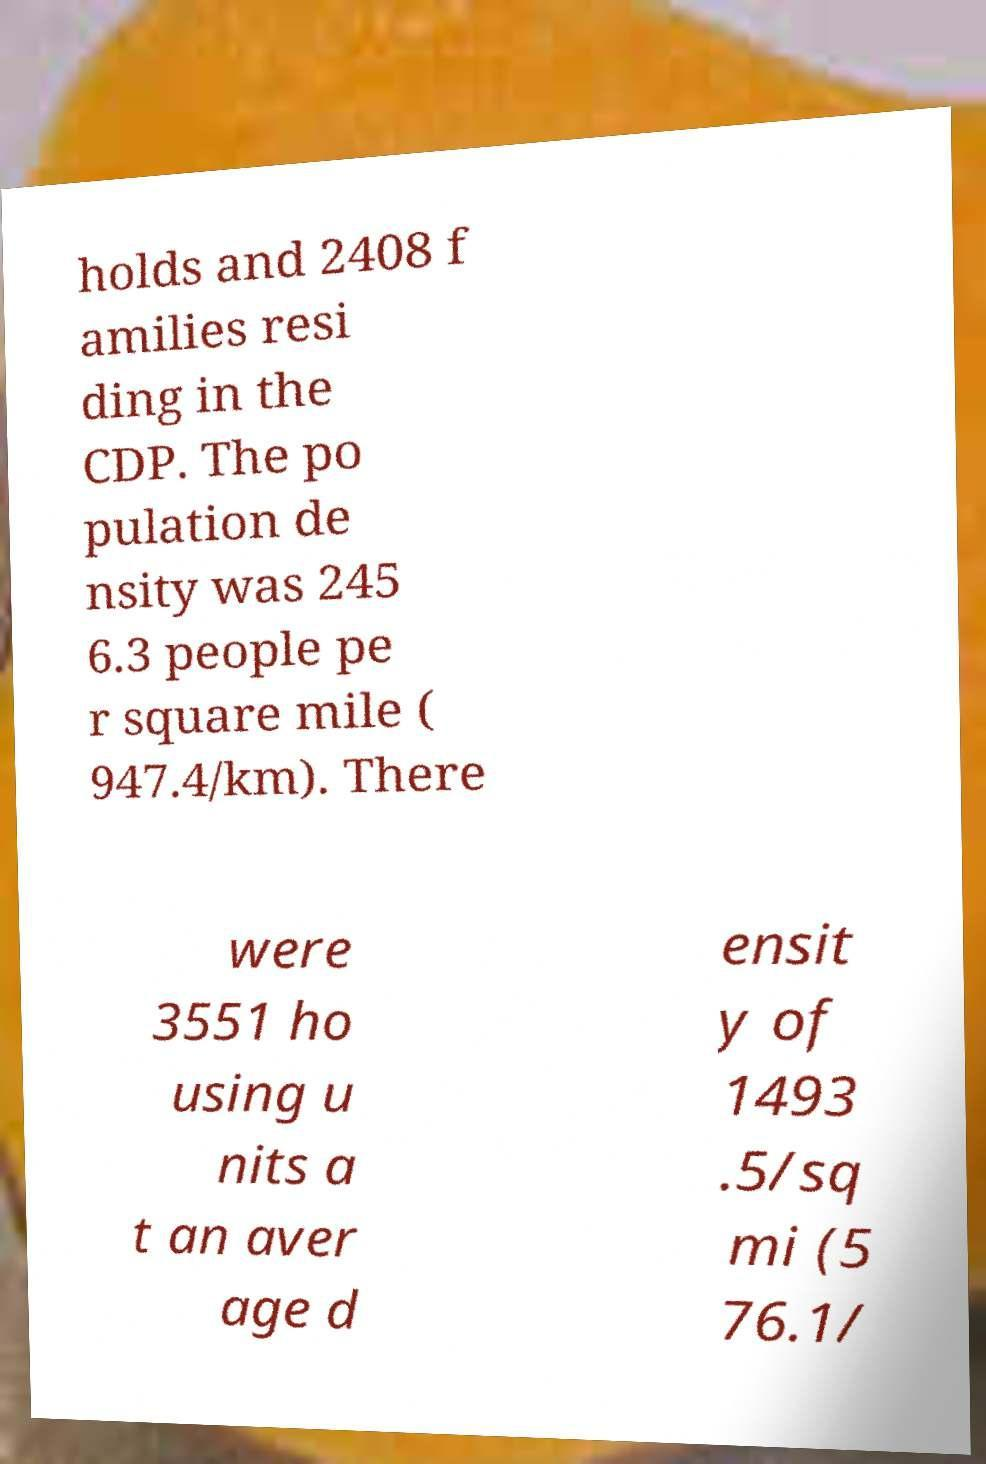There's text embedded in this image that I need extracted. Can you transcribe it verbatim? holds and 2408 f amilies resi ding in the CDP. The po pulation de nsity was 245 6.3 people pe r square mile ( 947.4/km). There were 3551 ho using u nits a t an aver age d ensit y of 1493 .5/sq mi (5 76.1/ 